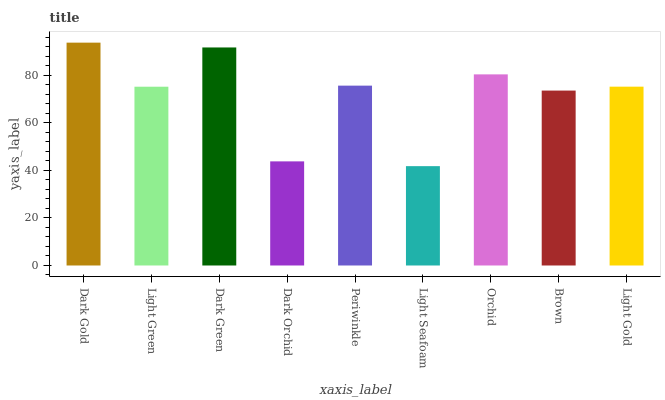Is Light Seafoam the minimum?
Answer yes or no. Yes. Is Dark Gold the maximum?
Answer yes or no. Yes. Is Light Green the minimum?
Answer yes or no. No. Is Light Green the maximum?
Answer yes or no. No. Is Dark Gold greater than Light Green?
Answer yes or no. Yes. Is Light Green less than Dark Gold?
Answer yes or no. Yes. Is Light Green greater than Dark Gold?
Answer yes or no. No. Is Dark Gold less than Light Green?
Answer yes or no. No. Is Light Gold the high median?
Answer yes or no. Yes. Is Light Gold the low median?
Answer yes or no. Yes. Is Light Seafoam the high median?
Answer yes or no. No. Is Light Seafoam the low median?
Answer yes or no. No. 